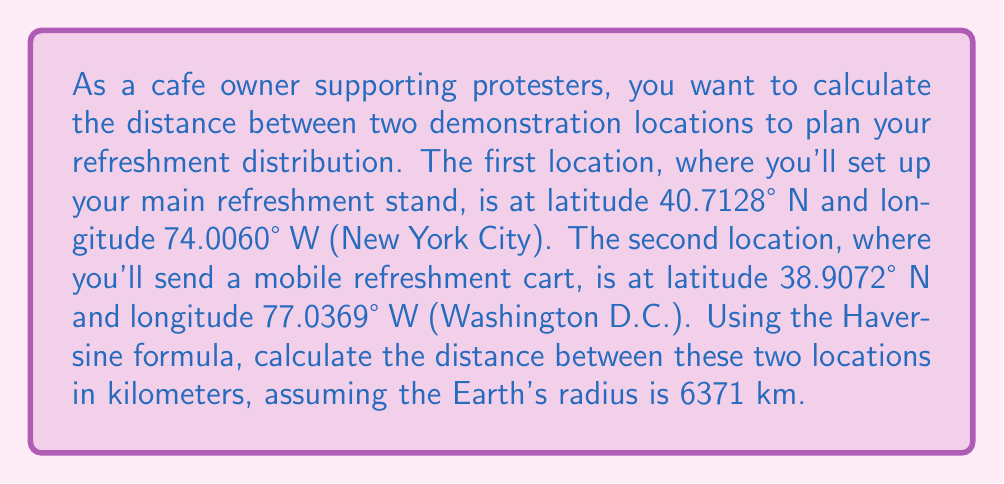Show me your answer to this math problem. To calculate the distance between two points on the Earth's surface using their latitude and longitude coordinates, we can use the Haversine formula. This formula takes into account the Earth's curvature.

Step 1: Convert the latitudes and longitudes from degrees to radians.
$\text{lat}_1 = 40.7128° \times \frac{\pi}{180} = 0.7101 \text{ radians}$
$\text{lon}_1 = -74.0060° \times \frac{\pi}{180} = -1.2915 \text{ radians}$
$\text{lat}_2 = 38.9072° \times \frac{\pi}{180} = 0.6790 \text{ radians}$
$\text{lon}_2 = -77.0369° \times \frac{\pi}{180} = -1.3444 \text{ radians}$

Step 2: Calculate the differences in latitude and longitude.
$\Delta\text{lat} = \text{lat}_2 - \text{lat}_1 = 0.6790 - 0.7101 = -0.0311 \text{ radians}$
$\Delta\text{lon} = \text{lon}_2 - \text{lon}_1 = -1.3444 - (-1.2915) = -0.0529 \text{ radians}$

Step 3: Apply the Haversine formula.
$$a = \sin^2(\frac{\Delta\text{lat}}{2}) + \cos(\text{lat}_1) \times \cos(\text{lat}_2) \times \sin^2(\frac{\Delta\text{lon}}{2})$$

$$c = 2 \times \text{atan2}(\sqrt{a}, \sqrt{1-a})$$

$$d = R \times c$$

Where $R$ is the Earth's radius (6371 km).

Step 4: Calculate the values.
$a = \sin^2(-0.0156) + \cos(0.7101) \times \cos(0.6790) \times \sin^2(-0.0265) = 0.0002401$

$c = 2 \times \text{atan2}(\sqrt{0.0002401}, \sqrt{1-0.0002401}) = 0.0309$

$d = 6371 \times 0.0309 = 196.87 \text{ km}$

Therefore, the distance between the two demonstration locations is approximately 196.87 km.
Answer: 196.87 km 